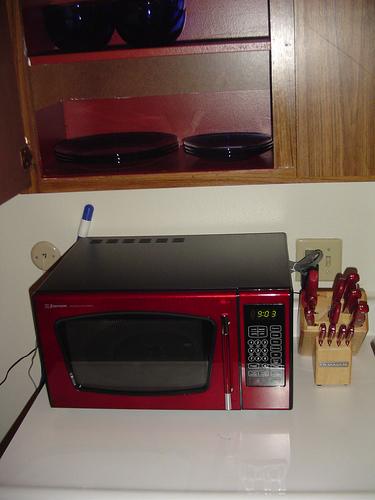Does the microwave color match the knives?
Write a very short answer. Yes. Is the microwave plugged in?
Quick response, please. Yes. What is on the top right side of the shelf?
Quick response, please. Plate. What is in the block next to the microwave?
Short answer required. Knives. What color is the microwave?
Concise answer only. Red. What time is it on microwave?
Concise answer only. 9:03. 